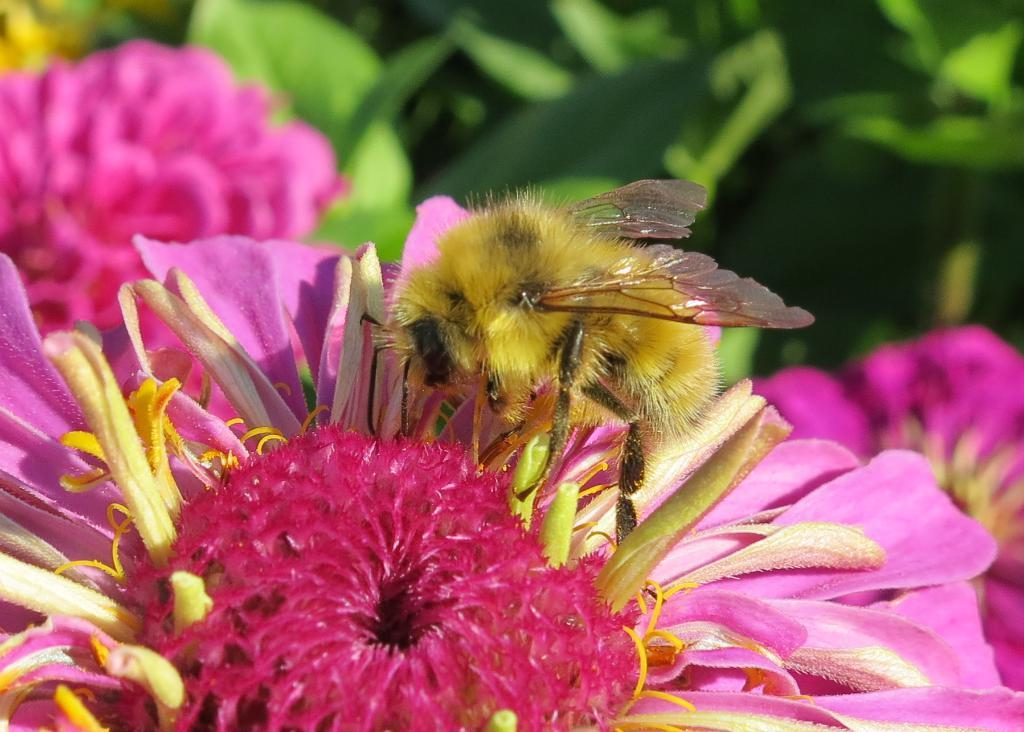What is on the flower in the image? There is an insect on a flower in the image. What can be seen in the background of the image? There are flowers and leaves visible in the background of the image. How does the insect expand its wings during the rainstorm in the image? There is no rainstorm present in the image, and the insect's wings are not shown expanding. 